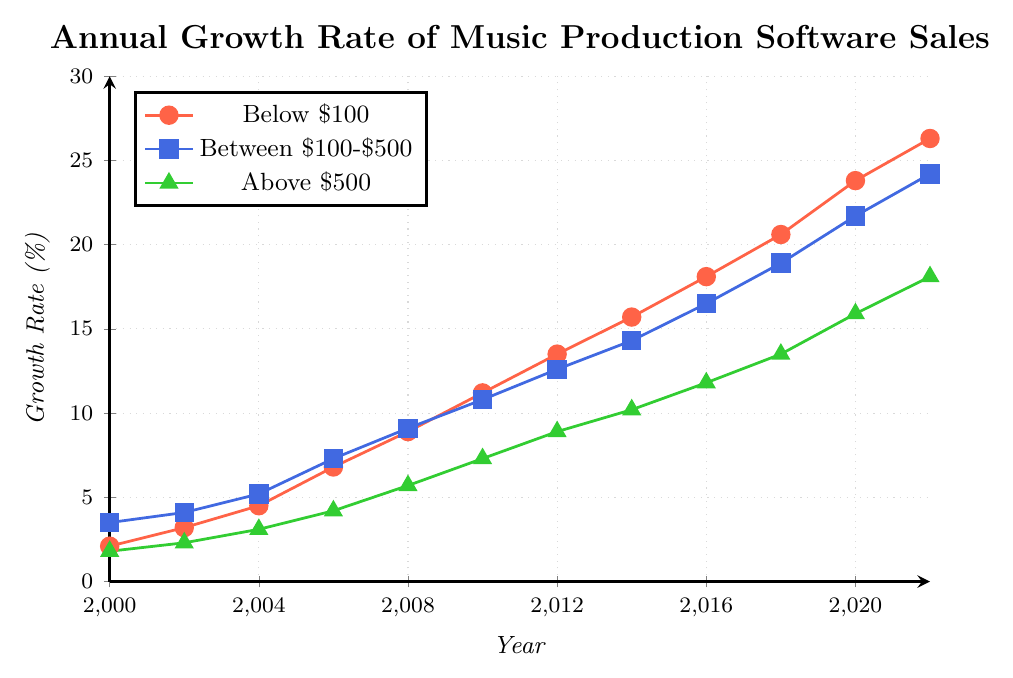Which price range had the highest sales growth rate in 2022? To find the highest growth rate in 2022, look at the data points for 2022 across all price ranges. The values are 26.3% for Below $100, 24.2% for Between $100-$500, and 18.1% for Above $500. The highest value is 26.3% for Below $100.
Answer: Below $100 What is the average annual growth rate of the Below $100 category from 2000 to 2022? Sum all the growth rates for Below $100 from 2000 to 2022 and divide by the number of years: (2.1 + 3.2 + 4.5 + 6.8 + 8.9 + 11.2 + 13.5 + 15.7 + 18.1 + 20.6 + 23.8 + 26.3) / 12. The sum is 154.7, and the average is 154.7 / 12.
Answer: 12.89% How does the growth rate of Between $100-$500 in 2012 compare to its growth rate in 2008? Look at the data points for Between $100-$500 in 2012 and 2008. The growth rate is 12.6% in 2012 and 9.1% in 2008. 12.6% is higher than 9.1%.
Answer: Higher What is the total increase in the growth rate for the Above $500 category from 2000 to 2022? Subtract the growth rate in 2000 from the growth rate in 2022 for the Above $500 category: 18.1% - 1.8%.
Answer: 16.3% Which price range had the slowest growth rate in 2016? Compare the growth rates of all price ranges in 2016. The values are 18.1% for Below $100, 16.5% for Between $100-$500, and 11.8% for Above $500. The lowest value is 11.8%.
Answer: Above $500 What is the overall trend of the growth rates for all categories from 2000 to 2022? Observe the line plot for each category from 2000 to 2022. All lines are increasing, indicating an upward trend for all price categories.
Answer: Upward trend How much higher is the growth rate for Below $100 than Above $500 in 2020? Subtract the growth rate of Above $500 from Below $100 in 2020: 23.8% - 15.9%.
Answer: 7.9% What is the difference between the highest growth rate and the lowest growth rate in 2014? Compare the growth rates across all categories in 2014. The values are 15.7% for Below $100, 14.3% for Between $100-$500, and 10.2% for Above $500. The difference is 15.7% - 10.2%.
Answer: 5.5% Which price range showed the most consistent growth over the years? Examine the smoothness and consistency of the lines. The Above $500 category shows a steady and consistent increase, with smaller fluctuations compared to the other categories.
Answer: Above $500 